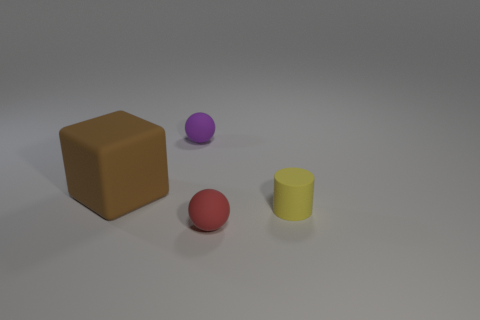What kind of material do these objects look like they're made of? The objects in the image have a matte appearance, implying that they could be made of plastic or possibly wood. The lack of reflective properties on their surfaces leads to this conclusion. 